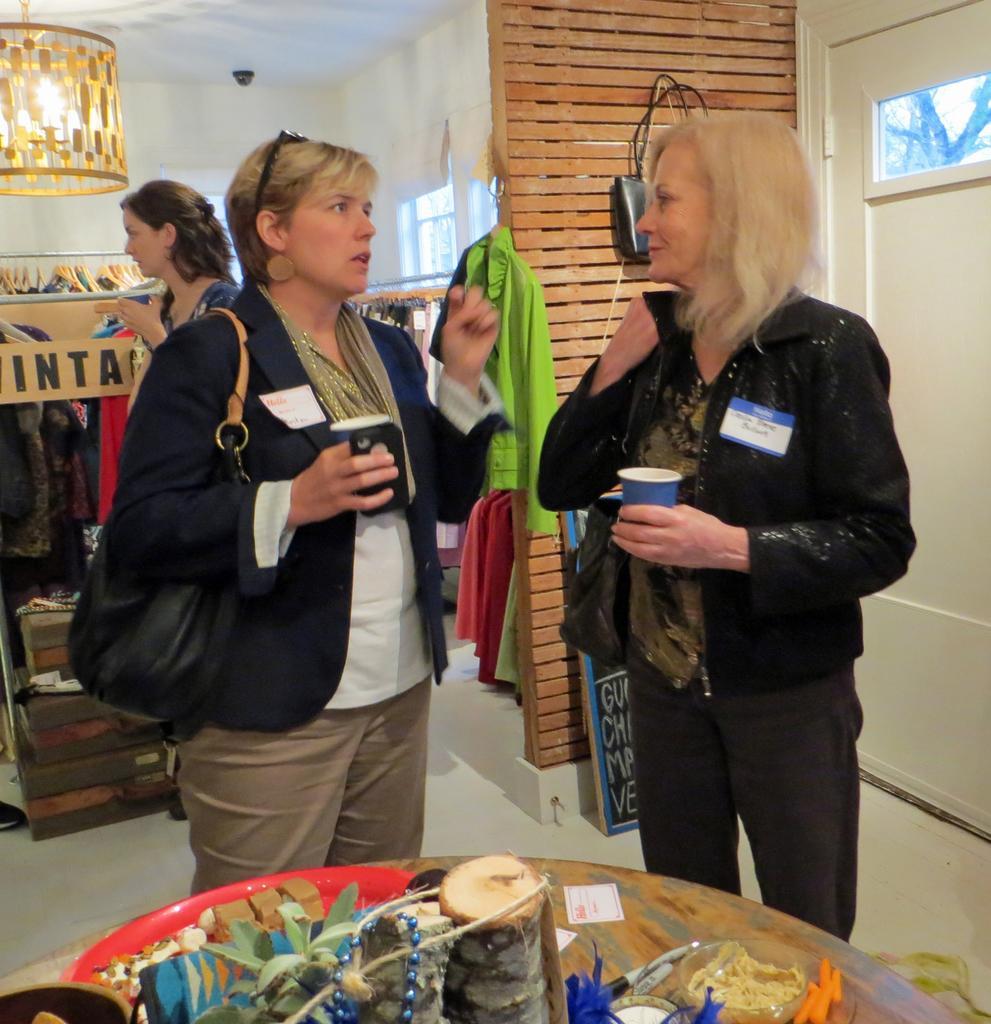Describe this image in one or two sentences. In this image we can see three people, they are holding glasses, two of them are wearing bags, there are clothes hung to the hangers, there are some objects on the table, there is a board with text on it, also we can see a door, a CCTV camera, and the walls. 